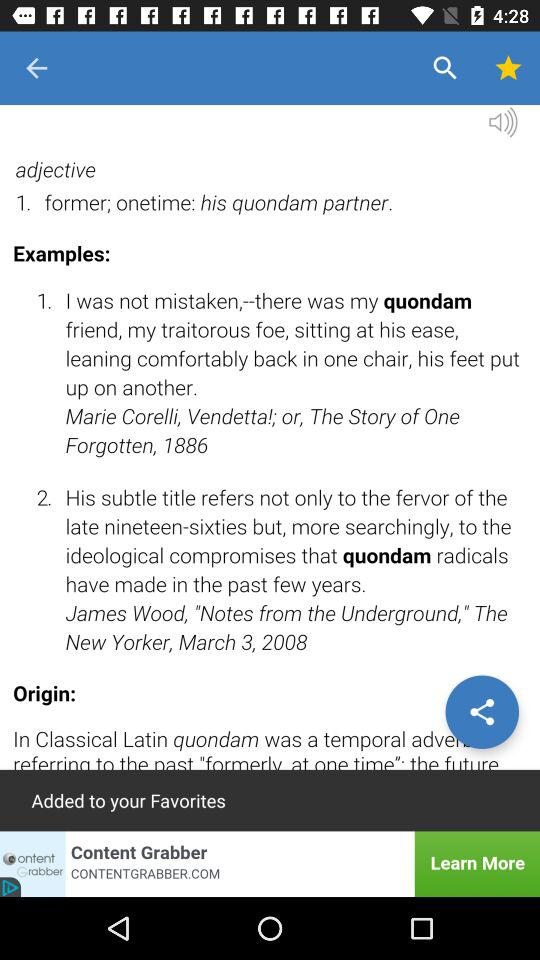How many examples are there on this page?
Answer the question using a single word or phrase. 2 